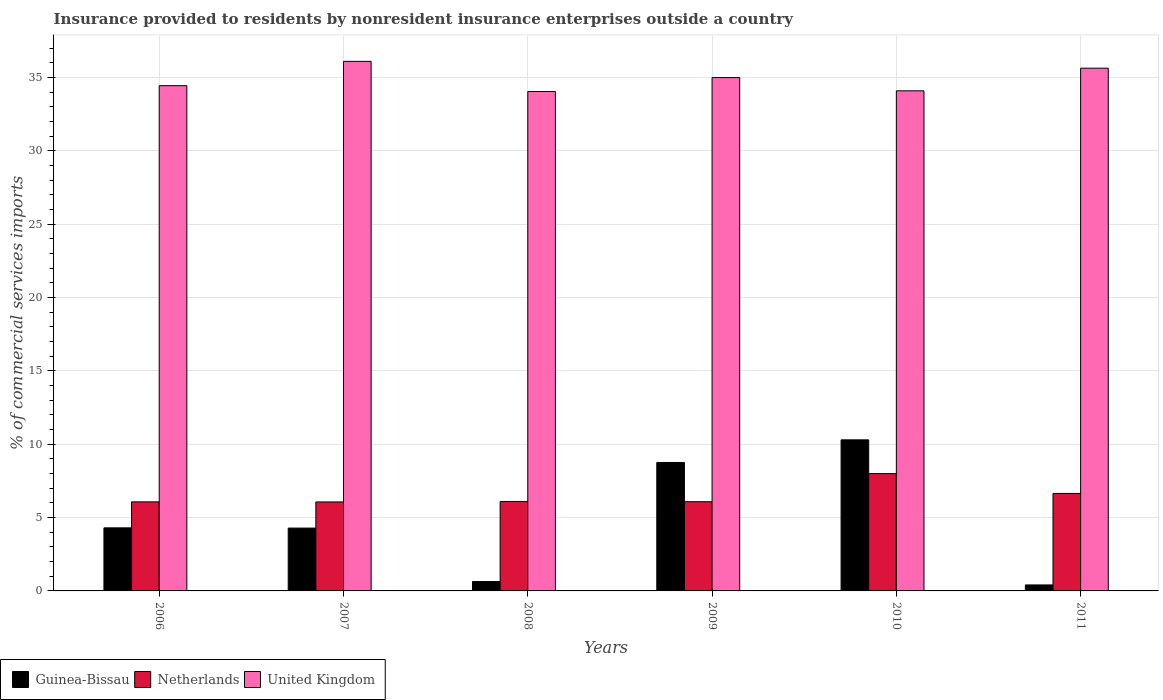How many different coloured bars are there?
Offer a very short reply. 3. How many bars are there on the 4th tick from the left?
Provide a short and direct response. 3. How many bars are there on the 4th tick from the right?
Offer a very short reply. 3. What is the label of the 1st group of bars from the left?
Make the answer very short. 2006. In how many cases, is the number of bars for a given year not equal to the number of legend labels?
Your response must be concise. 0. What is the Insurance provided to residents in United Kingdom in 2009?
Make the answer very short. 34.99. Across all years, what is the maximum Insurance provided to residents in Guinea-Bissau?
Offer a very short reply. 10.3. Across all years, what is the minimum Insurance provided to residents in Guinea-Bissau?
Your answer should be very brief. 0.41. In which year was the Insurance provided to residents in Netherlands maximum?
Your response must be concise. 2010. In which year was the Insurance provided to residents in Netherlands minimum?
Make the answer very short. 2007. What is the total Insurance provided to residents in United Kingdom in the graph?
Offer a very short reply. 209.29. What is the difference between the Insurance provided to residents in Guinea-Bissau in 2007 and that in 2009?
Offer a terse response. -4.47. What is the difference between the Insurance provided to residents in United Kingdom in 2011 and the Insurance provided to residents in Guinea-Bissau in 2008?
Provide a succinct answer. 34.99. What is the average Insurance provided to residents in United Kingdom per year?
Make the answer very short. 34.88. In the year 2008, what is the difference between the Insurance provided to residents in Guinea-Bissau and Insurance provided to residents in United Kingdom?
Make the answer very short. -33.4. In how many years, is the Insurance provided to residents in Netherlands greater than 9 %?
Your answer should be very brief. 0. What is the ratio of the Insurance provided to residents in Guinea-Bissau in 2007 to that in 2010?
Offer a terse response. 0.42. Is the Insurance provided to residents in United Kingdom in 2006 less than that in 2009?
Ensure brevity in your answer.  Yes. Is the difference between the Insurance provided to residents in Guinea-Bissau in 2006 and 2008 greater than the difference between the Insurance provided to residents in United Kingdom in 2006 and 2008?
Provide a short and direct response. Yes. What is the difference between the highest and the second highest Insurance provided to residents in Guinea-Bissau?
Your response must be concise. 1.54. What is the difference between the highest and the lowest Insurance provided to residents in United Kingdom?
Your answer should be compact. 2.05. In how many years, is the Insurance provided to residents in Guinea-Bissau greater than the average Insurance provided to residents in Guinea-Bissau taken over all years?
Offer a very short reply. 2. What does the 2nd bar from the right in 2007 represents?
Your response must be concise. Netherlands. How many bars are there?
Make the answer very short. 18. How many years are there in the graph?
Keep it short and to the point. 6. What is the difference between two consecutive major ticks on the Y-axis?
Provide a short and direct response. 5. Does the graph contain any zero values?
Make the answer very short. No. Where does the legend appear in the graph?
Provide a succinct answer. Bottom left. What is the title of the graph?
Provide a short and direct response. Insurance provided to residents by nonresident insurance enterprises outside a country. Does "Latvia" appear as one of the legend labels in the graph?
Keep it short and to the point. No. What is the label or title of the Y-axis?
Give a very brief answer. % of commercial services imports. What is the % of commercial services imports in Guinea-Bissau in 2006?
Your answer should be very brief. 4.3. What is the % of commercial services imports in Netherlands in 2006?
Provide a short and direct response. 6.07. What is the % of commercial services imports in United Kingdom in 2006?
Give a very brief answer. 34.44. What is the % of commercial services imports of Guinea-Bissau in 2007?
Give a very brief answer. 4.28. What is the % of commercial services imports of Netherlands in 2007?
Offer a terse response. 6.06. What is the % of commercial services imports of United Kingdom in 2007?
Offer a very short reply. 36.1. What is the % of commercial services imports of Guinea-Bissau in 2008?
Make the answer very short. 0.64. What is the % of commercial services imports in Netherlands in 2008?
Offer a terse response. 6.1. What is the % of commercial services imports in United Kingdom in 2008?
Offer a terse response. 34.04. What is the % of commercial services imports in Guinea-Bissau in 2009?
Your answer should be very brief. 8.76. What is the % of commercial services imports in Netherlands in 2009?
Give a very brief answer. 6.08. What is the % of commercial services imports of United Kingdom in 2009?
Offer a very short reply. 34.99. What is the % of commercial services imports of Guinea-Bissau in 2010?
Your response must be concise. 10.3. What is the % of commercial services imports in Netherlands in 2010?
Your answer should be compact. 8. What is the % of commercial services imports of United Kingdom in 2010?
Make the answer very short. 34.09. What is the % of commercial services imports in Guinea-Bissau in 2011?
Ensure brevity in your answer.  0.41. What is the % of commercial services imports in Netherlands in 2011?
Provide a short and direct response. 6.65. What is the % of commercial services imports in United Kingdom in 2011?
Provide a short and direct response. 35.63. Across all years, what is the maximum % of commercial services imports in Guinea-Bissau?
Provide a short and direct response. 10.3. Across all years, what is the maximum % of commercial services imports of Netherlands?
Give a very brief answer. 8. Across all years, what is the maximum % of commercial services imports in United Kingdom?
Your answer should be very brief. 36.1. Across all years, what is the minimum % of commercial services imports of Guinea-Bissau?
Your response must be concise. 0.41. Across all years, what is the minimum % of commercial services imports in Netherlands?
Your response must be concise. 6.06. Across all years, what is the minimum % of commercial services imports of United Kingdom?
Your answer should be compact. 34.04. What is the total % of commercial services imports in Guinea-Bissau in the graph?
Your response must be concise. 28.68. What is the total % of commercial services imports in Netherlands in the graph?
Give a very brief answer. 38.96. What is the total % of commercial services imports in United Kingdom in the graph?
Offer a very short reply. 209.29. What is the difference between the % of commercial services imports in Guinea-Bissau in 2006 and that in 2007?
Offer a very short reply. 0.02. What is the difference between the % of commercial services imports in Netherlands in 2006 and that in 2007?
Make the answer very short. 0.01. What is the difference between the % of commercial services imports in United Kingdom in 2006 and that in 2007?
Make the answer very short. -1.66. What is the difference between the % of commercial services imports of Guinea-Bissau in 2006 and that in 2008?
Offer a terse response. 3.66. What is the difference between the % of commercial services imports of Netherlands in 2006 and that in 2008?
Offer a very short reply. -0.03. What is the difference between the % of commercial services imports of United Kingdom in 2006 and that in 2008?
Make the answer very short. 0.4. What is the difference between the % of commercial services imports of Guinea-Bissau in 2006 and that in 2009?
Offer a very short reply. -4.46. What is the difference between the % of commercial services imports in Netherlands in 2006 and that in 2009?
Offer a terse response. -0.01. What is the difference between the % of commercial services imports in United Kingdom in 2006 and that in 2009?
Offer a terse response. -0.55. What is the difference between the % of commercial services imports in Guinea-Bissau in 2006 and that in 2010?
Your response must be concise. -6. What is the difference between the % of commercial services imports of Netherlands in 2006 and that in 2010?
Offer a very short reply. -1.93. What is the difference between the % of commercial services imports in United Kingdom in 2006 and that in 2010?
Keep it short and to the point. 0.35. What is the difference between the % of commercial services imports in Guinea-Bissau in 2006 and that in 2011?
Keep it short and to the point. 3.89. What is the difference between the % of commercial services imports of Netherlands in 2006 and that in 2011?
Your response must be concise. -0.58. What is the difference between the % of commercial services imports in United Kingdom in 2006 and that in 2011?
Offer a terse response. -1.19. What is the difference between the % of commercial services imports of Guinea-Bissau in 2007 and that in 2008?
Make the answer very short. 3.64. What is the difference between the % of commercial services imports of Netherlands in 2007 and that in 2008?
Your answer should be very brief. -0.03. What is the difference between the % of commercial services imports of United Kingdom in 2007 and that in 2008?
Offer a very short reply. 2.06. What is the difference between the % of commercial services imports of Guinea-Bissau in 2007 and that in 2009?
Your answer should be compact. -4.47. What is the difference between the % of commercial services imports of Netherlands in 2007 and that in 2009?
Give a very brief answer. -0.02. What is the difference between the % of commercial services imports of United Kingdom in 2007 and that in 2009?
Your response must be concise. 1.11. What is the difference between the % of commercial services imports of Guinea-Bissau in 2007 and that in 2010?
Provide a short and direct response. -6.02. What is the difference between the % of commercial services imports of Netherlands in 2007 and that in 2010?
Your answer should be very brief. -1.93. What is the difference between the % of commercial services imports in United Kingdom in 2007 and that in 2010?
Your response must be concise. 2.01. What is the difference between the % of commercial services imports in Guinea-Bissau in 2007 and that in 2011?
Your response must be concise. 3.87. What is the difference between the % of commercial services imports in Netherlands in 2007 and that in 2011?
Make the answer very short. -0.58. What is the difference between the % of commercial services imports in United Kingdom in 2007 and that in 2011?
Give a very brief answer. 0.47. What is the difference between the % of commercial services imports in Guinea-Bissau in 2008 and that in 2009?
Your answer should be compact. -8.12. What is the difference between the % of commercial services imports in Netherlands in 2008 and that in 2009?
Give a very brief answer. 0.02. What is the difference between the % of commercial services imports of United Kingdom in 2008 and that in 2009?
Keep it short and to the point. -0.95. What is the difference between the % of commercial services imports of Guinea-Bissau in 2008 and that in 2010?
Offer a very short reply. -9.66. What is the difference between the % of commercial services imports in Netherlands in 2008 and that in 2010?
Provide a short and direct response. -1.9. What is the difference between the % of commercial services imports in United Kingdom in 2008 and that in 2010?
Your response must be concise. -0.05. What is the difference between the % of commercial services imports in Guinea-Bissau in 2008 and that in 2011?
Offer a very short reply. 0.23. What is the difference between the % of commercial services imports of Netherlands in 2008 and that in 2011?
Your answer should be very brief. -0.55. What is the difference between the % of commercial services imports of United Kingdom in 2008 and that in 2011?
Your answer should be compact. -1.59. What is the difference between the % of commercial services imports of Guinea-Bissau in 2009 and that in 2010?
Your answer should be very brief. -1.54. What is the difference between the % of commercial services imports in Netherlands in 2009 and that in 2010?
Provide a short and direct response. -1.92. What is the difference between the % of commercial services imports in United Kingdom in 2009 and that in 2010?
Your answer should be compact. 0.9. What is the difference between the % of commercial services imports in Guinea-Bissau in 2009 and that in 2011?
Offer a terse response. 8.35. What is the difference between the % of commercial services imports in Netherlands in 2009 and that in 2011?
Provide a short and direct response. -0.56. What is the difference between the % of commercial services imports of United Kingdom in 2009 and that in 2011?
Keep it short and to the point. -0.64. What is the difference between the % of commercial services imports of Guinea-Bissau in 2010 and that in 2011?
Your answer should be compact. 9.89. What is the difference between the % of commercial services imports of Netherlands in 2010 and that in 2011?
Make the answer very short. 1.35. What is the difference between the % of commercial services imports in United Kingdom in 2010 and that in 2011?
Offer a terse response. -1.54. What is the difference between the % of commercial services imports in Guinea-Bissau in 2006 and the % of commercial services imports in Netherlands in 2007?
Your answer should be very brief. -1.77. What is the difference between the % of commercial services imports in Guinea-Bissau in 2006 and the % of commercial services imports in United Kingdom in 2007?
Offer a very short reply. -31.8. What is the difference between the % of commercial services imports in Netherlands in 2006 and the % of commercial services imports in United Kingdom in 2007?
Provide a short and direct response. -30.03. What is the difference between the % of commercial services imports of Guinea-Bissau in 2006 and the % of commercial services imports of Netherlands in 2008?
Your response must be concise. -1.8. What is the difference between the % of commercial services imports in Guinea-Bissau in 2006 and the % of commercial services imports in United Kingdom in 2008?
Provide a succinct answer. -29.74. What is the difference between the % of commercial services imports of Netherlands in 2006 and the % of commercial services imports of United Kingdom in 2008?
Offer a very short reply. -27.97. What is the difference between the % of commercial services imports of Guinea-Bissau in 2006 and the % of commercial services imports of Netherlands in 2009?
Your answer should be very brief. -1.78. What is the difference between the % of commercial services imports of Guinea-Bissau in 2006 and the % of commercial services imports of United Kingdom in 2009?
Your answer should be very brief. -30.69. What is the difference between the % of commercial services imports of Netherlands in 2006 and the % of commercial services imports of United Kingdom in 2009?
Your answer should be compact. -28.92. What is the difference between the % of commercial services imports of Guinea-Bissau in 2006 and the % of commercial services imports of Netherlands in 2010?
Your response must be concise. -3.7. What is the difference between the % of commercial services imports in Guinea-Bissau in 2006 and the % of commercial services imports in United Kingdom in 2010?
Offer a very short reply. -29.79. What is the difference between the % of commercial services imports of Netherlands in 2006 and the % of commercial services imports of United Kingdom in 2010?
Your response must be concise. -28.02. What is the difference between the % of commercial services imports of Guinea-Bissau in 2006 and the % of commercial services imports of Netherlands in 2011?
Provide a succinct answer. -2.35. What is the difference between the % of commercial services imports of Guinea-Bissau in 2006 and the % of commercial services imports of United Kingdom in 2011?
Your response must be concise. -31.33. What is the difference between the % of commercial services imports of Netherlands in 2006 and the % of commercial services imports of United Kingdom in 2011?
Your answer should be compact. -29.56. What is the difference between the % of commercial services imports in Guinea-Bissau in 2007 and the % of commercial services imports in Netherlands in 2008?
Provide a succinct answer. -1.81. What is the difference between the % of commercial services imports in Guinea-Bissau in 2007 and the % of commercial services imports in United Kingdom in 2008?
Offer a terse response. -29.76. What is the difference between the % of commercial services imports of Netherlands in 2007 and the % of commercial services imports of United Kingdom in 2008?
Give a very brief answer. -27.98. What is the difference between the % of commercial services imports of Guinea-Bissau in 2007 and the % of commercial services imports of Netherlands in 2009?
Provide a short and direct response. -1.8. What is the difference between the % of commercial services imports in Guinea-Bissau in 2007 and the % of commercial services imports in United Kingdom in 2009?
Keep it short and to the point. -30.71. What is the difference between the % of commercial services imports of Netherlands in 2007 and the % of commercial services imports of United Kingdom in 2009?
Ensure brevity in your answer.  -28.93. What is the difference between the % of commercial services imports in Guinea-Bissau in 2007 and the % of commercial services imports in Netherlands in 2010?
Your answer should be compact. -3.71. What is the difference between the % of commercial services imports of Guinea-Bissau in 2007 and the % of commercial services imports of United Kingdom in 2010?
Provide a succinct answer. -29.81. What is the difference between the % of commercial services imports in Netherlands in 2007 and the % of commercial services imports in United Kingdom in 2010?
Ensure brevity in your answer.  -28.02. What is the difference between the % of commercial services imports in Guinea-Bissau in 2007 and the % of commercial services imports in Netherlands in 2011?
Ensure brevity in your answer.  -2.36. What is the difference between the % of commercial services imports of Guinea-Bissau in 2007 and the % of commercial services imports of United Kingdom in 2011?
Make the answer very short. -31.35. What is the difference between the % of commercial services imports of Netherlands in 2007 and the % of commercial services imports of United Kingdom in 2011?
Your answer should be compact. -29.57. What is the difference between the % of commercial services imports of Guinea-Bissau in 2008 and the % of commercial services imports of Netherlands in 2009?
Your response must be concise. -5.44. What is the difference between the % of commercial services imports of Guinea-Bissau in 2008 and the % of commercial services imports of United Kingdom in 2009?
Ensure brevity in your answer.  -34.35. What is the difference between the % of commercial services imports of Netherlands in 2008 and the % of commercial services imports of United Kingdom in 2009?
Keep it short and to the point. -28.89. What is the difference between the % of commercial services imports in Guinea-Bissau in 2008 and the % of commercial services imports in Netherlands in 2010?
Your response must be concise. -7.36. What is the difference between the % of commercial services imports of Guinea-Bissau in 2008 and the % of commercial services imports of United Kingdom in 2010?
Make the answer very short. -33.45. What is the difference between the % of commercial services imports in Netherlands in 2008 and the % of commercial services imports in United Kingdom in 2010?
Offer a very short reply. -27.99. What is the difference between the % of commercial services imports of Guinea-Bissau in 2008 and the % of commercial services imports of Netherlands in 2011?
Your answer should be compact. -6.01. What is the difference between the % of commercial services imports of Guinea-Bissau in 2008 and the % of commercial services imports of United Kingdom in 2011?
Your answer should be compact. -34.99. What is the difference between the % of commercial services imports of Netherlands in 2008 and the % of commercial services imports of United Kingdom in 2011?
Provide a short and direct response. -29.53. What is the difference between the % of commercial services imports of Guinea-Bissau in 2009 and the % of commercial services imports of Netherlands in 2010?
Offer a very short reply. 0.76. What is the difference between the % of commercial services imports in Guinea-Bissau in 2009 and the % of commercial services imports in United Kingdom in 2010?
Provide a succinct answer. -25.33. What is the difference between the % of commercial services imports in Netherlands in 2009 and the % of commercial services imports in United Kingdom in 2010?
Provide a succinct answer. -28.01. What is the difference between the % of commercial services imports of Guinea-Bissau in 2009 and the % of commercial services imports of Netherlands in 2011?
Your answer should be compact. 2.11. What is the difference between the % of commercial services imports of Guinea-Bissau in 2009 and the % of commercial services imports of United Kingdom in 2011?
Offer a very short reply. -26.88. What is the difference between the % of commercial services imports of Netherlands in 2009 and the % of commercial services imports of United Kingdom in 2011?
Offer a very short reply. -29.55. What is the difference between the % of commercial services imports in Guinea-Bissau in 2010 and the % of commercial services imports in Netherlands in 2011?
Provide a succinct answer. 3.65. What is the difference between the % of commercial services imports in Guinea-Bissau in 2010 and the % of commercial services imports in United Kingdom in 2011?
Provide a succinct answer. -25.33. What is the difference between the % of commercial services imports in Netherlands in 2010 and the % of commercial services imports in United Kingdom in 2011?
Offer a terse response. -27.64. What is the average % of commercial services imports in Guinea-Bissau per year?
Provide a short and direct response. 4.78. What is the average % of commercial services imports in Netherlands per year?
Make the answer very short. 6.49. What is the average % of commercial services imports of United Kingdom per year?
Your answer should be compact. 34.88. In the year 2006, what is the difference between the % of commercial services imports in Guinea-Bissau and % of commercial services imports in Netherlands?
Provide a succinct answer. -1.77. In the year 2006, what is the difference between the % of commercial services imports in Guinea-Bissau and % of commercial services imports in United Kingdom?
Give a very brief answer. -30.14. In the year 2006, what is the difference between the % of commercial services imports of Netherlands and % of commercial services imports of United Kingdom?
Your answer should be very brief. -28.37. In the year 2007, what is the difference between the % of commercial services imports of Guinea-Bissau and % of commercial services imports of Netherlands?
Give a very brief answer. -1.78. In the year 2007, what is the difference between the % of commercial services imports of Guinea-Bissau and % of commercial services imports of United Kingdom?
Your answer should be compact. -31.81. In the year 2007, what is the difference between the % of commercial services imports in Netherlands and % of commercial services imports in United Kingdom?
Ensure brevity in your answer.  -30.03. In the year 2008, what is the difference between the % of commercial services imports in Guinea-Bissau and % of commercial services imports in Netherlands?
Provide a short and direct response. -5.46. In the year 2008, what is the difference between the % of commercial services imports in Guinea-Bissau and % of commercial services imports in United Kingdom?
Provide a short and direct response. -33.4. In the year 2008, what is the difference between the % of commercial services imports in Netherlands and % of commercial services imports in United Kingdom?
Your answer should be compact. -27.95. In the year 2009, what is the difference between the % of commercial services imports of Guinea-Bissau and % of commercial services imports of Netherlands?
Offer a terse response. 2.67. In the year 2009, what is the difference between the % of commercial services imports of Guinea-Bissau and % of commercial services imports of United Kingdom?
Offer a terse response. -26.24. In the year 2009, what is the difference between the % of commercial services imports of Netherlands and % of commercial services imports of United Kingdom?
Your answer should be very brief. -28.91. In the year 2010, what is the difference between the % of commercial services imports in Guinea-Bissau and % of commercial services imports in Netherlands?
Make the answer very short. 2.3. In the year 2010, what is the difference between the % of commercial services imports in Guinea-Bissau and % of commercial services imports in United Kingdom?
Offer a very short reply. -23.79. In the year 2010, what is the difference between the % of commercial services imports in Netherlands and % of commercial services imports in United Kingdom?
Give a very brief answer. -26.09. In the year 2011, what is the difference between the % of commercial services imports in Guinea-Bissau and % of commercial services imports in Netherlands?
Your answer should be very brief. -6.24. In the year 2011, what is the difference between the % of commercial services imports of Guinea-Bissau and % of commercial services imports of United Kingdom?
Offer a very short reply. -35.22. In the year 2011, what is the difference between the % of commercial services imports of Netherlands and % of commercial services imports of United Kingdom?
Provide a succinct answer. -28.99. What is the ratio of the % of commercial services imports in Guinea-Bissau in 2006 to that in 2007?
Make the answer very short. 1. What is the ratio of the % of commercial services imports of Netherlands in 2006 to that in 2007?
Keep it short and to the point. 1. What is the ratio of the % of commercial services imports of United Kingdom in 2006 to that in 2007?
Your response must be concise. 0.95. What is the ratio of the % of commercial services imports in Guinea-Bissau in 2006 to that in 2008?
Your response must be concise. 6.72. What is the ratio of the % of commercial services imports in Netherlands in 2006 to that in 2008?
Ensure brevity in your answer.  1. What is the ratio of the % of commercial services imports in United Kingdom in 2006 to that in 2008?
Offer a very short reply. 1.01. What is the ratio of the % of commercial services imports of Guinea-Bissau in 2006 to that in 2009?
Provide a succinct answer. 0.49. What is the ratio of the % of commercial services imports in United Kingdom in 2006 to that in 2009?
Your answer should be very brief. 0.98. What is the ratio of the % of commercial services imports of Guinea-Bissau in 2006 to that in 2010?
Ensure brevity in your answer.  0.42. What is the ratio of the % of commercial services imports of Netherlands in 2006 to that in 2010?
Give a very brief answer. 0.76. What is the ratio of the % of commercial services imports of United Kingdom in 2006 to that in 2010?
Ensure brevity in your answer.  1.01. What is the ratio of the % of commercial services imports of Guinea-Bissau in 2006 to that in 2011?
Offer a very short reply. 10.53. What is the ratio of the % of commercial services imports of Netherlands in 2006 to that in 2011?
Make the answer very short. 0.91. What is the ratio of the % of commercial services imports of United Kingdom in 2006 to that in 2011?
Your answer should be very brief. 0.97. What is the ratio of the % of commercial services imports in Guinea-Bissau in 2007 to that in 2008?
Your answer should be very brief. 6.69. What is the ratio of the % of commercial services imports in Netherlands in 2007 to that in 2008?
Provide a succinct answer. 0.99. What is the ratio of the % of commercial services imports of United Kingdom in 2007 to that in 2008?
Your answer should be very brief. 1.06. What is the ratio of the % of commercial services imports of Guinea-Bissau in 2007 to that in 2009?
Make the answer very short. 0.49. What is the ratio of the % of commercial services imports in United Kingdom in 2007 to that in 2009?
Provide a succinct answer. 1.03. What is the ratio of the % of commercial services imports of Guinea-Bissau in 2007 to that in 2010?
Make the answer very short. 0.42. What is the ratio of the % of commercial services imports of Netherlands in 2007 to that in 2010?
Provide a succinct answer. 0.76. What is the ratio of the % of commercial services imports of United Kingdom in 2007 to that in 2010?
Offer a very short reply. 1.06. What is the ratio of the % of commercial services imports in Guinea-Bissau in 2007 to that in 2011?
Offer a terse response. 10.49. What is the ratio of the % of commercial services imports of Netherlands in 2007 to that in 2011?
Offer a very short reply. 0.91. What is the ratio of the % of commercial services imports in United Kingdom in 2007 to that in 2011?
Provide a short and direct response. 1.01. What is the ratio of the % of commercial services imports in Guinea-Bissau in 2008 to that in 2009?
Provide a succinct answer. 0.07. What is the ratio of the % of commercial services imports in Netherlands in 2008 to that in 2009?
Offer a terse response. 1. What is the ratio of the % of commercial services imports in United Kingdom in 2008 to that in 2009?
Provide a succinct answer. 0.97. What is the ratio of the % of commercial services imports of Guinea-Bissau in 2008 to that in 2010?
Ensure brevity in your answer.  0.06. What is the ratio of the % of commercial services imports of Netherlands in 2008 to that in 2010?
Ensure brevity in your answer.  0.76. What is the ratio of the % of commercial services imports of Guinea-Bissau in 2008 to that in 2011?
Give a very brief answer. 1.57. What is the ratio of the % of commercial services imports in Netherlands in 2008 to that in 2011?
Offer a terse response. 0.92. What is the ratio of the % of commercial services imports of United Kingdom in 2008 to that in 2011?
Keep it short and to the point. 0.96. What is the ratio of the % of commercial services imports of Guinea-Bissau in 2009 to that in 2010?
Ensure brevity in your answer.  0.85. What is the ratio of the % of commercial services imports of Netherlands in 2009 to that in 2010?
Offer a very short reply. 0.76. What is the ratio of the % of commercial services imports of United Kingdom in 2009 to that in 2010?
Offer a very short reply. 1.03. What is the ratio of the % of commercial services imports in Guinea-Bissau in 2009 to that in 2011?
Make the answer very short. 21.45. What is the ratio of the % of commercial services imports in Netherlands in 2009 to that in 2011?
Give a very brief answer. 0.92. What is the ratio of the % of commercial services imports in United Kingdom in 2009 to that in 2011?
Provide a succinct answer. 0.98. What is the ratio of the % of commercial services imports in Guinea-Bissau in 2010 to that in 2011?
Provide a short and direct response. 25.23. What is the ratio of the % of commercial services imports of Netherlands in 2010 to that in 2011?
Ensure brevity in your answer.  1.2. What is the ratio of the % of commercial services imports of United Kingdom in 2010 to that in 2011?
Give a very brief answer. 0.96. What is the difference between the highest and the second highest % of commercial services imports in Guinea-Bissau?
Ensure brevity in your answer.  1.54. What is the difference between the highest and the second highest % of commercial services imports of Netherlands?
Offer a terse response. 1.35. What is the difference between the highest and the second highest % of commercial services imports of United Kingdom?
Give a very brief answer. 0.47. What is the difference between the highest and the lowest % of commercial services imports in Guinea-Bissau?
Your response must be concise. 9.89. What is the difference between the highest and the lowest % of commercial services imports in Netherlands?
Make the answer very short. 1.93. What is the difference between the highest and the lowest % of commercial services imports of United Kingdom?
Ensure brevity in your answer.  2.06. 